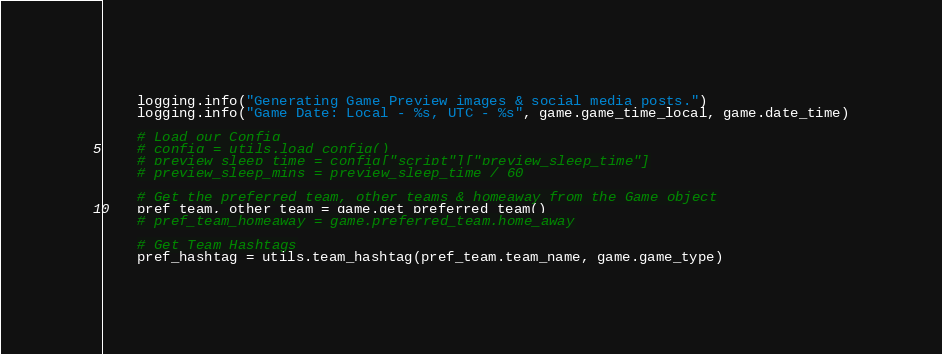Convert code to text. <code><loc_0><loc_0><loc_500><loc_500><_Python_>    logging.info("Generating Game Preview images & social media posts.")
    logging.info("Game Date: Local - %s, UTC - %s", game.game_time_local, game.date_time)

    # Load our Config
    # config = utils.load_config()
    # preview_sleep_time = config["script"]["preview_sleep_time"]
    # preview_sleep_mins = preview_sleep_time / 60

    # Get the preferred team, other teams & homeaway from the Game object
    pref_team, other_team = game.get_preferred_team()
    # pref_team_homeaway = game.preferred_team.home_away

    # Get Team Hashtags
    pref_hashtag = utils.team_hashtag(pref_team.team_name, game.game_type)</code> 